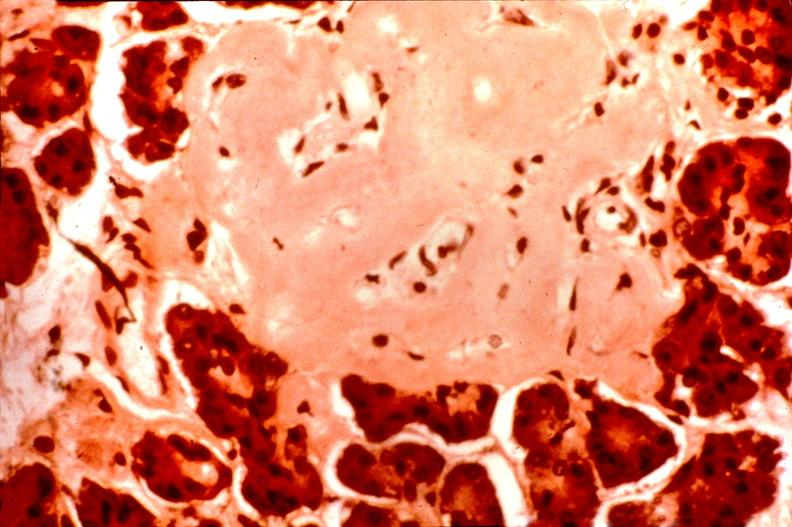does nodular tumor show pancrease, islet amyloid, diabetes mellitus?
Answer the question using a single word or phrase. No 